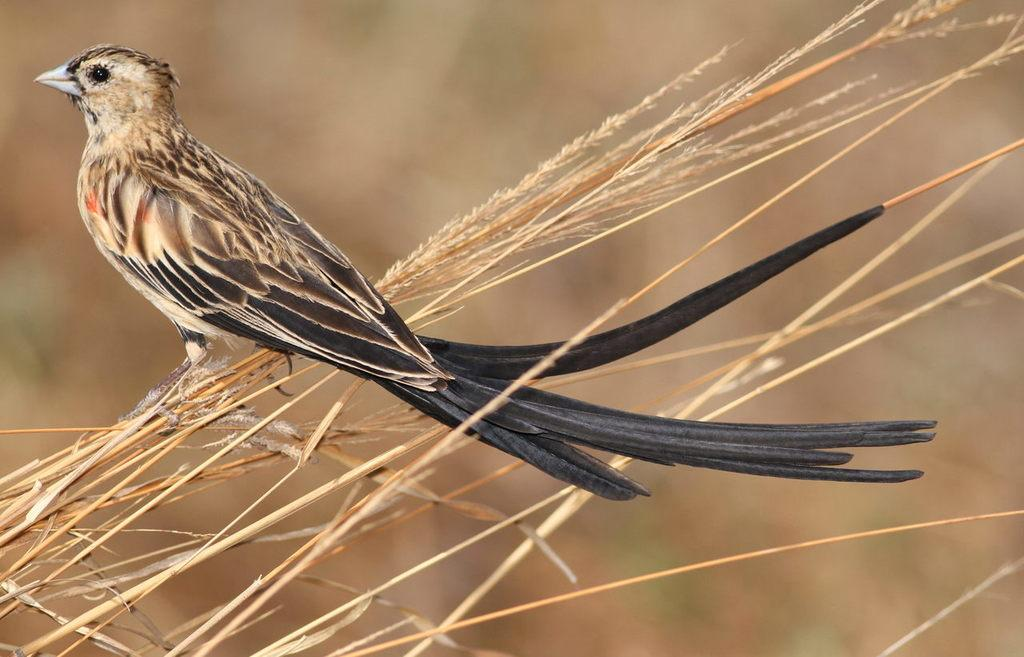What type of animal can be seen in the image? There is a bird in the image. Where is the bird located? The bird is on the grass. Can you describe the background of the image? The background of the image is blurry. What type of shop can be seen in the background of the image? There is no shop present in the image; the background is blurry. What type of songs is the bird singing in the image? Birds do not sing songs like humans do, and there is no indication in the image that the bird is singing. 